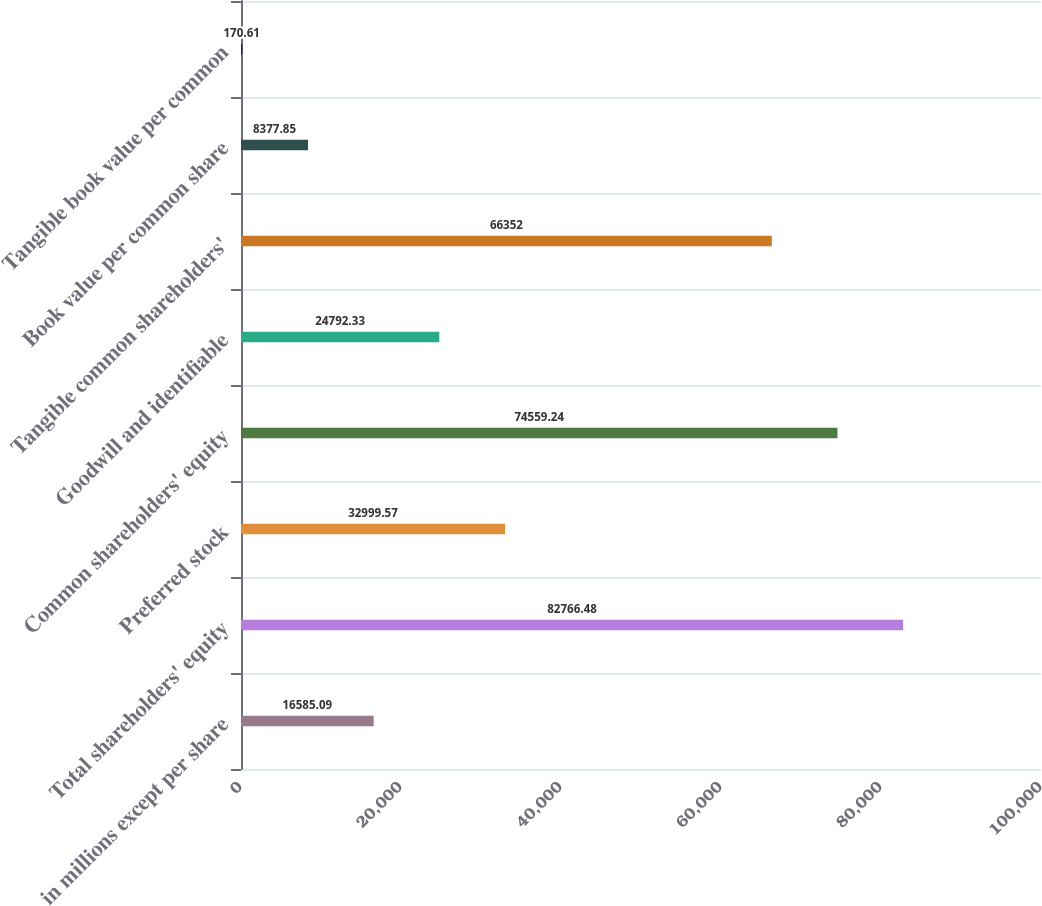<chart> <loc_0><loc_0><loc_500><loc_500><bar_chart><fcel>in millions except per share<fcel>Total shareholders' equity<fcel>Preferred stock<fcel>Common shareholders' equity<fcel>Goodwill and identifiable<fcel>Tangible common shareholders'<fcel>Book value per common share<fcel>Tangible book value per common<nl><fcel>16585.1<fcel>82766.5<fcel>32999.6<fcel>74559.2<fcel>24792.3<fcel>66352<fcel>8377.85<fcel>170.61<nl></chart> 